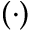<formula> <loc_0><loc_0><loc_500><loc_500>( \cdot )</formula> 